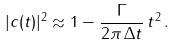Convert formula to latex. <formula><loc_0><loc_0><loc_500><loc_500>| c ( t ) | ^ { 2 } \approx 1 - \frac { \Gamma } { 2 \pi \, \Delta t } \, t ^ { 2 } \, .</formula> 